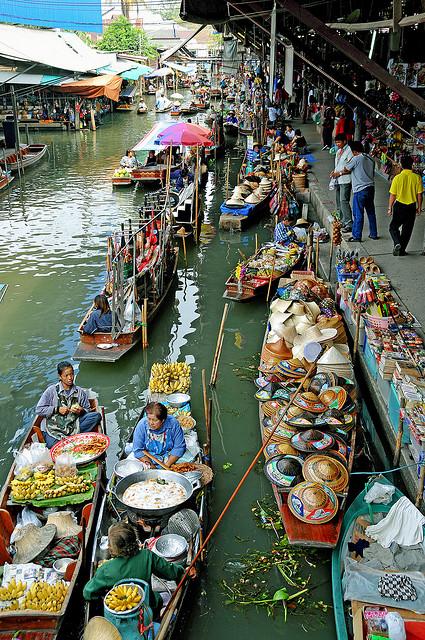Is this Italy?
Concise answer only. No. Is this in Asia?
Short answer required. Yes. How many boats are capsized?
Give a very brief answer. 0. 